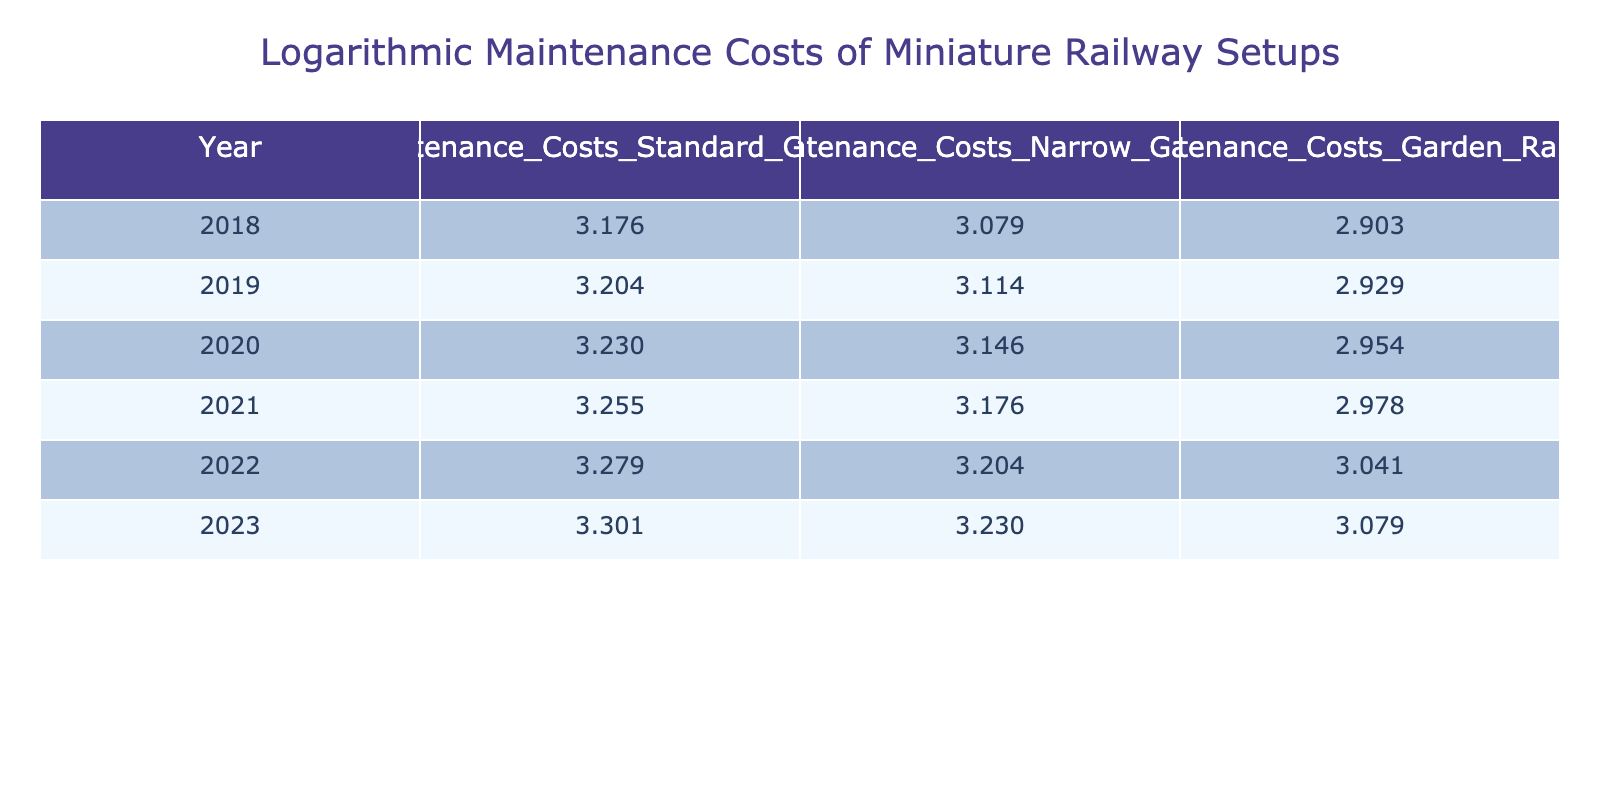What were the maintenance costs for the Standard Gauge in 2021? The table shows that the maintenance cost for the Standard Gauge in 2021 was 1800. This value can be directly found in the specific row corresponding to the year 2021.
Answer: 1800 What was the maintenance cost difference between the Narrow Gauge in 2022 and the Garden Railway in 2020? The maintenance cost for the Narrow Gauge in 2022 is 1600, and for the Garden Railway in 2020, it is 900. The difference is calculated as 1600 - 900 = 700.
Answer: 700 Did the maintenance costs for Standard Gauge increase every year from 2018 to 2023? Looking at the table, the maintenance costs for Standard Gauge increase each year without any decreases from 2018 to 2023.
Answer: Yes What was the average maintenance cost for the Garden Railway from 2018 to 2023? The costs for the Garden Railway over the years are as follows: 800 (2018), 850 (2019), 900 (2020), 950 (2021), 1100 (2022), and 1200 (2023). Summing these gives: 800 + 850 + 900 + 950 + 1100 + 1200 = 4850. To find the average, divide by the number of years (6), which equals 4850 / 6 = approximately 808.33.
Answer: 808.33 Which gauge had the lowest maintenance costs in 2019? In the table for 2019, the maintenance costs are as follows: Standard Gauge 1600, Narrow Gauge 1300, and Garden Railway 850. The lowest cost among these is for the Garden Railway at 850.
Answer: Garden Railway What is the logarithmic value of the maintenance costs for the Narrow Gauge in 2023? Referring to the table, the Narrow Gauge maintenance cost in 2023 is 1700. Applying a logarithmic transformation (log10) to this value gives approximately 3.230.
Answer: 3.230 Did the maintenance costs for the Garden Railway surpass 1000 in any year? The table shows that the Garden Railway maintenance costs were below 1000 for the years 2018 to 2021 (800, 850, 900, 950). However, in 2022 it was 1100, indicating it did surpass 1000 that year.
Answer: Yes What was the highest maintenance cost recorded for any gauge in 2022? In 2022, the recorded maintenance costs were Standard Gauge 1900, Narrow Gauge 1600, and Garden Railway 1100. The highest cost among these values is 1900, for the Standard Gauge.
Answer: 1900 